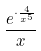<formula> <loc_0><loc_0><loc_500><loc_500>\frac { e ^ { \cdot \frac { 4 } { x ^ { 5 } } } } { x }</formula> 